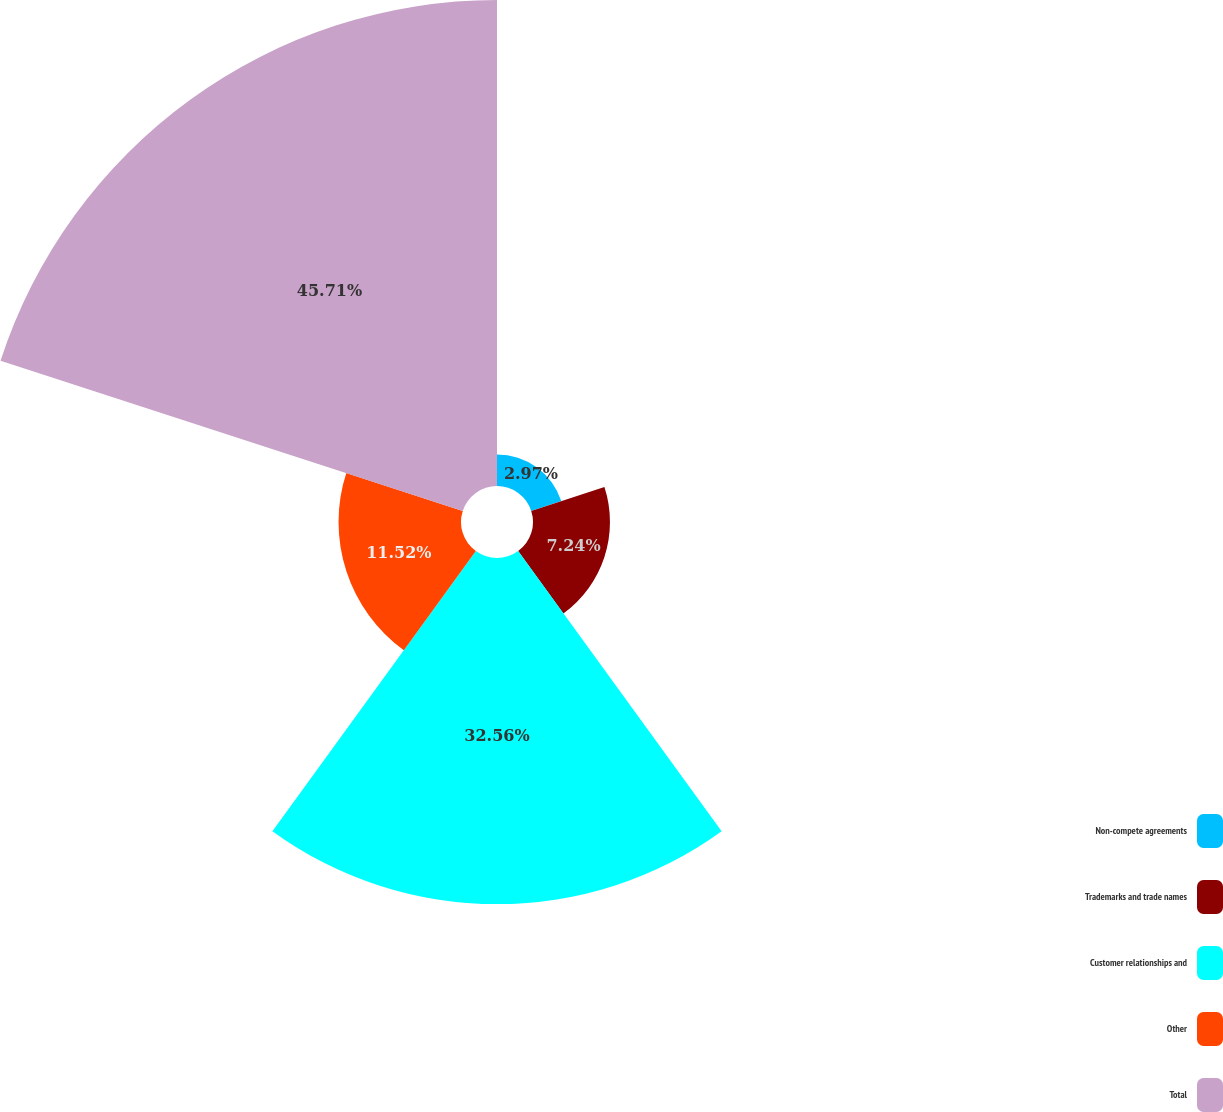Convert chart. <chart><loc_0><loc_0><loc_500><loc_500><pie_chart><fcel>Non-compete agreements<fcel>Trademarks and trade names<fcel>Customer relationships and<fcel>Other<fcel>Total<nl><fcel>2.97%<fcel>7.24%<fcel>32.56%<fcel>11.52%<fcel>45.72%<nl></chart> 